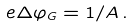<formula> <loc_0><loc_0><loc_500><loc_500>e \Delta \varphi _ { G } = 1 / A \, .</formula> 